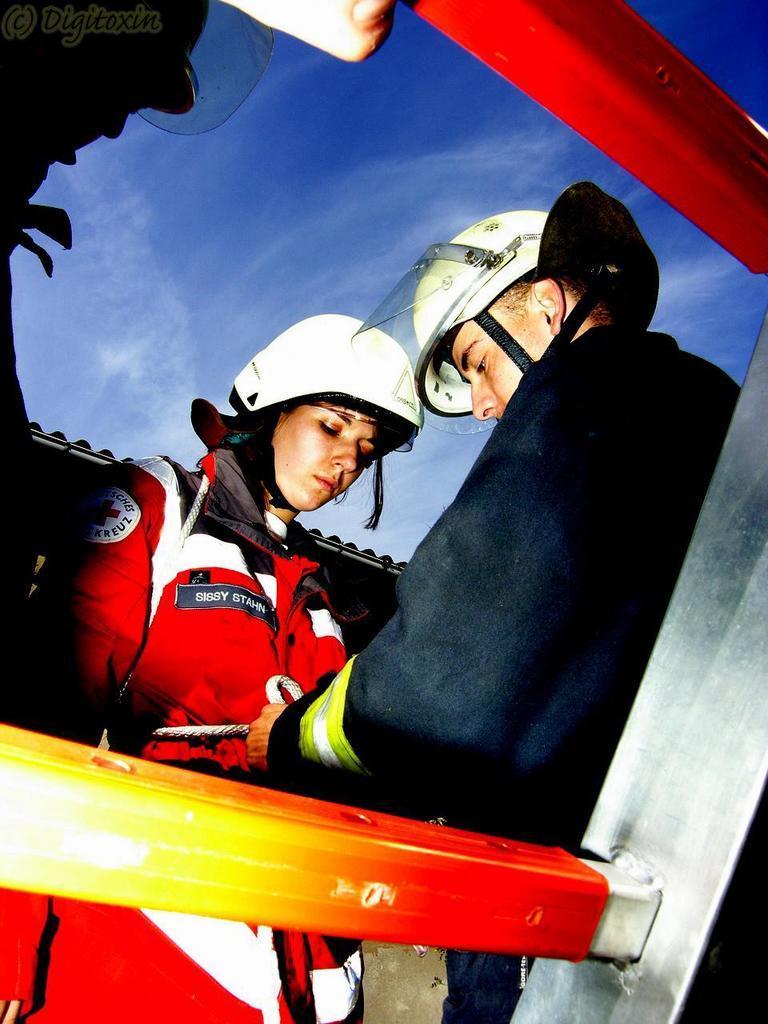Can you describe this image briefly? In this picture I can observe two members. One of them is a woman wearing red color jacket and white color helmet on her head and the other one is a man. In the background I can observe some clouds in the sky. 